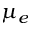<formula> <loc_0><loc_0><loc_500><loc_500>\mu _ { e }</formula> 